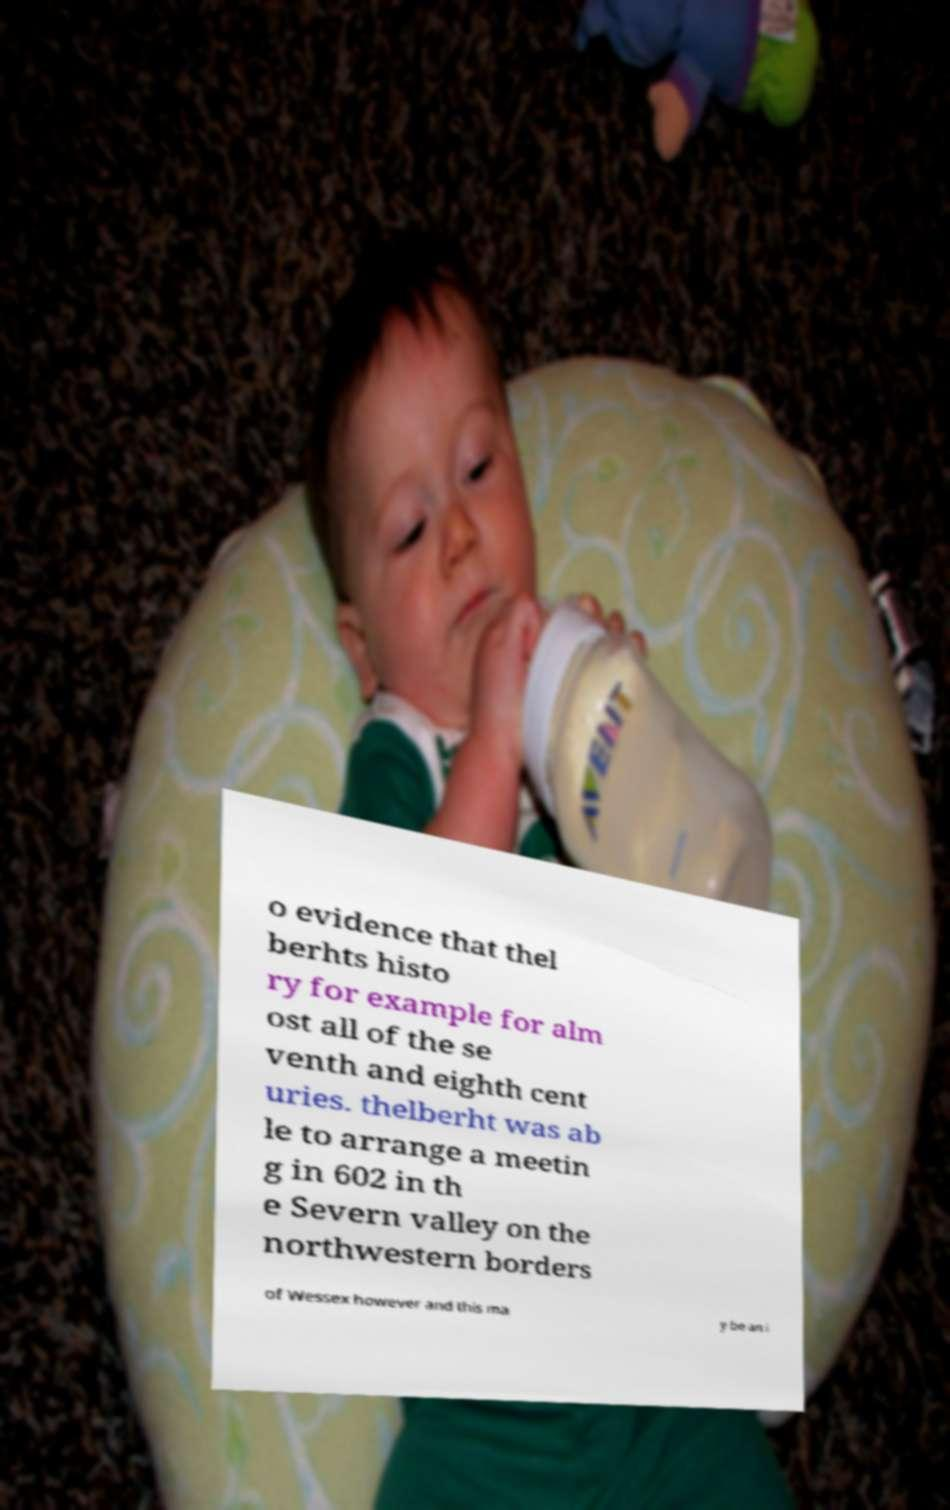Can you accurately transcribe the text from the provided image for me? o evidence that thel berhts histo ry for example for alm ost all of the se venth and eighth cent uries. thelberht was ab le to arrange a meetin g in 602 in th e Severn valley on the northwestern borders of Wessex however and this ma y be an i 